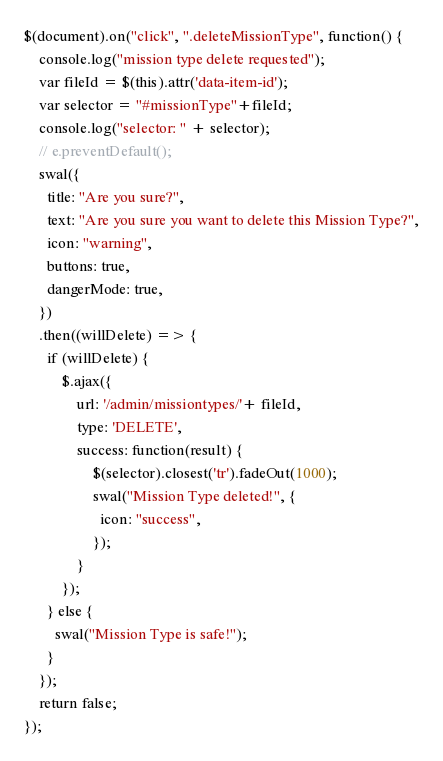<code> <loc_0><loc_0><loc_500><loc_500><_JavaScript_>$(document).on("click", ".deleteMissionType", function() {
    console.log("mission type delete requested");
    var fileId = $(this).attr('data-item-id');
    var selector = "#missionType"+fileId;
    console.log("selector: " + selector);
    // e.preventDefault();
    swal({
      title: "Are you sure?",
      text: "Are you sure you want to delete this Mission Type?",
      icon: "warning",
      buttons: true,
      dangerMode: true,
    })
    .then((willDelete) => {
      if (willDelete) {
          $.ajax({
              url: '/admin/missiontypes/'+ fileId,
              type: 'DELETE',
              success: function(result) {
                  $(selector).closest('tr').fadeOut(1000);
                  swal("Mission Type deleted!", {
                    icon: "success",
                  });
              }
          });
      } else {
        swal("Mission Type is safe!");
      }
    });
    return false;
});
</code> 